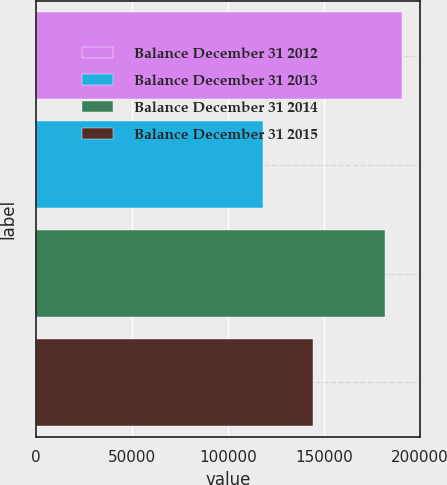Convert chart to OTSL. <chart><loc_0><loc_0><loc_500><loc_500><bar_chart><fcel>Balance December 31 2012<fcel>Balance December 31 2013<fcel>Balance December 31 2014<fcel>Balance December 31 2015<nl><fcel>190704<fcel>118190<fcel>181919<fcel>144185<nl></chart> 